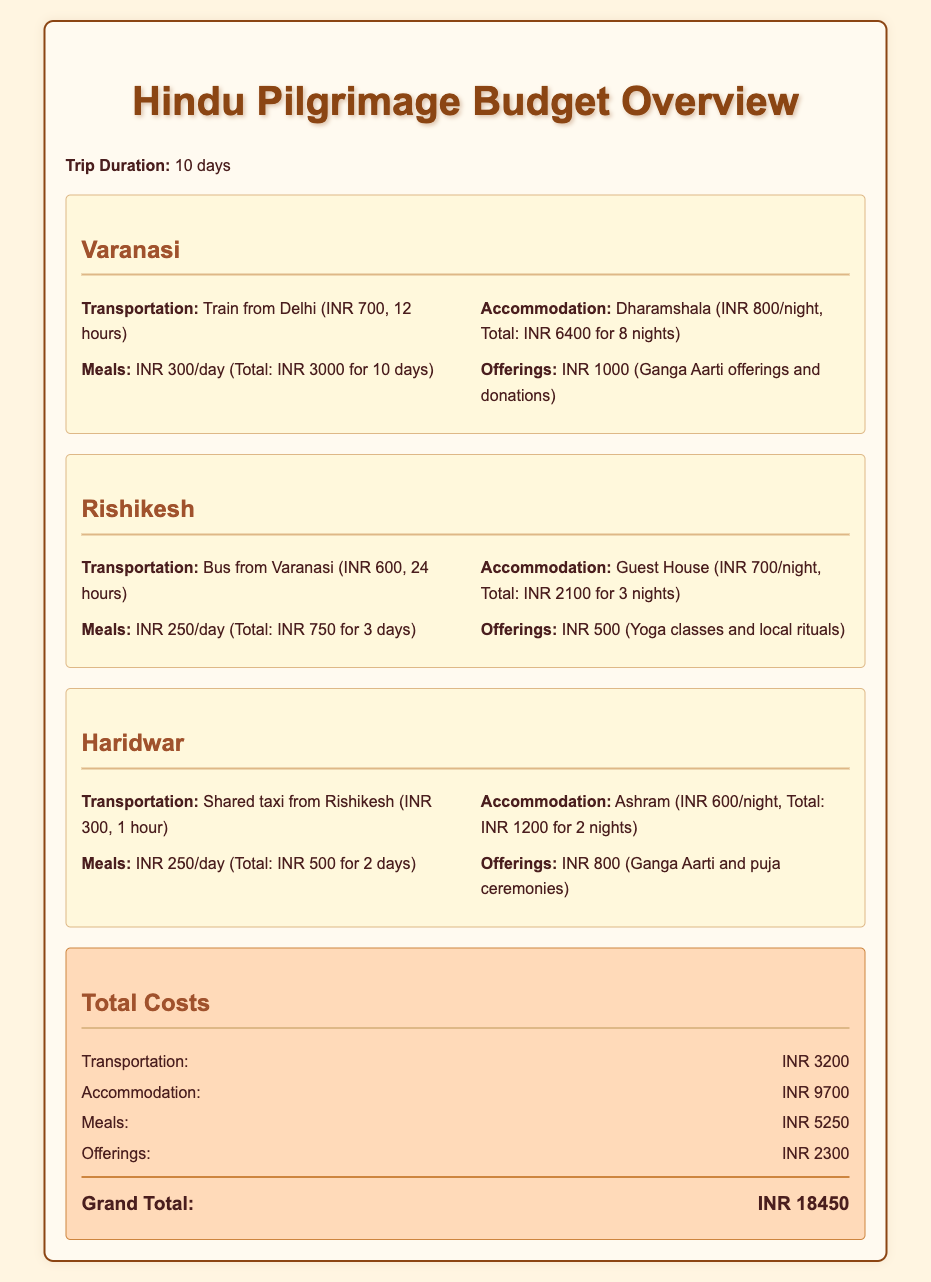What is the total budget for the trip? The total budget is listed in the document under "Grand Total" and is the sum of all costs.
Answer: INR 18450 How much is the transportation cost from Delhi to Varanasi? The transportation cost from Delhi to Varanasi is specified in the Varanasi section of the document.
Answer: INR 700 What is the cost of accommodation in Haridwar? The accommodation cost in Haridwar is listed under the Haridwar section in the document.
Answer: INR 1200 How many days will the trip last? The duration of the trip is stated at the beginning of the document.
Answer: 10 days What type of transportation is used to reach Rishikesh from Varanasi? The document specifies the mode of transportation in the Rishikesh section.
Answer: Bus What is the total cost of meals? The total meals cost is the sum of all daily meal expenses mentioned in the document.
Answer: INR 5250 How many nights will be spent in Varanasi? The number of nights in Varanasi is detailed in the Varanasi accommodation information.
Answer: 8 nights What offerings will be made in Rishikesh? The document discusses specific offerings in the Rishikesh section.
Answer: Yoga classes and local rituals What type of accommodation is provided in Rishikesh? The type of accommodation in Rishikesh is indicated in the corresponding section.
Answer: Guest House 